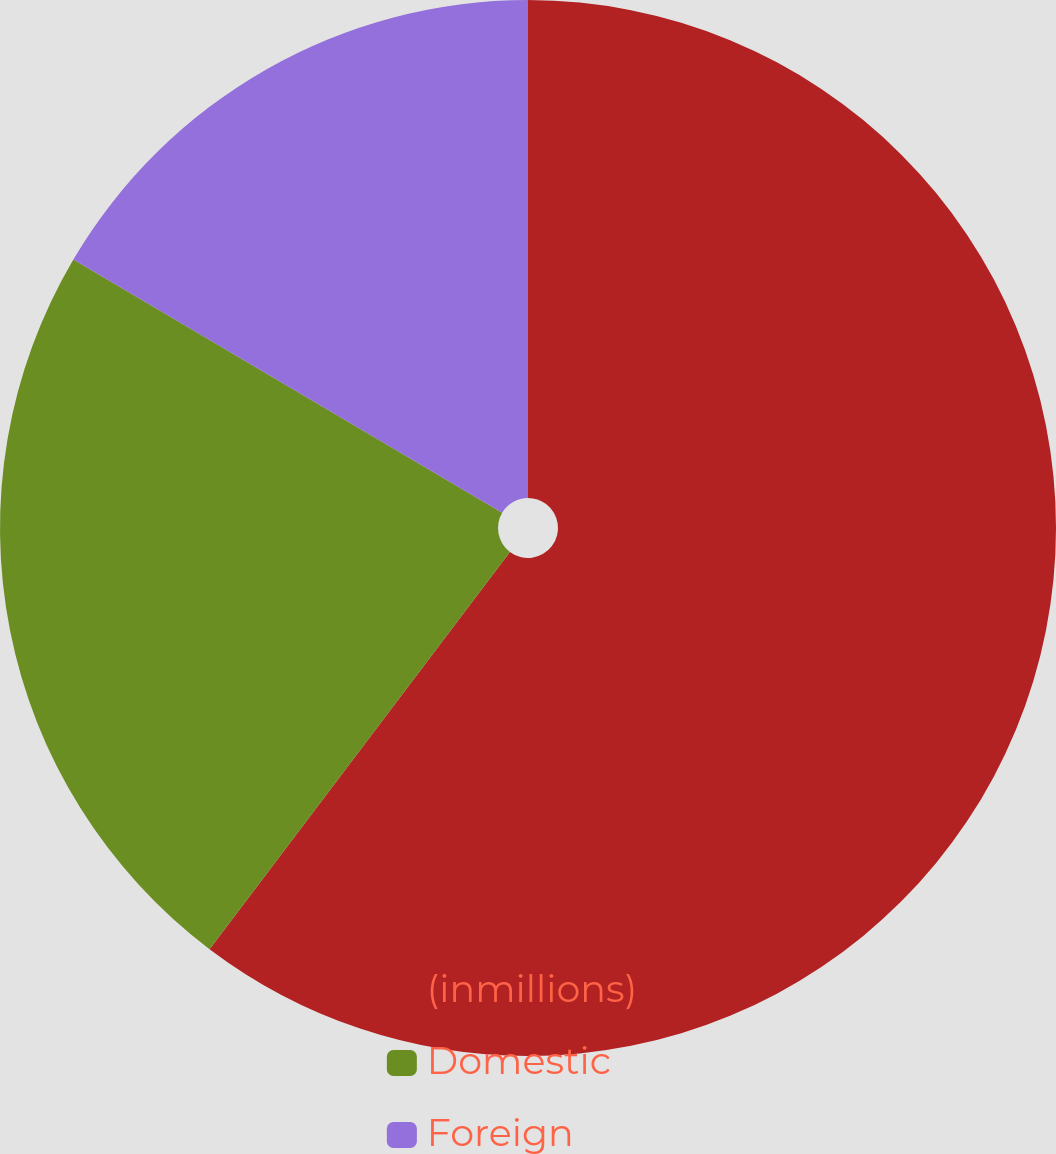<chart> <loc_0><loc_0><loc_500><loc_500><pie_chart><fcel>(inmillions)<fcel>Domestic<fcel>Foreign<nl><fcel>60.31%<fcel>23.19%<fcel>16.51%<nl></chart> 